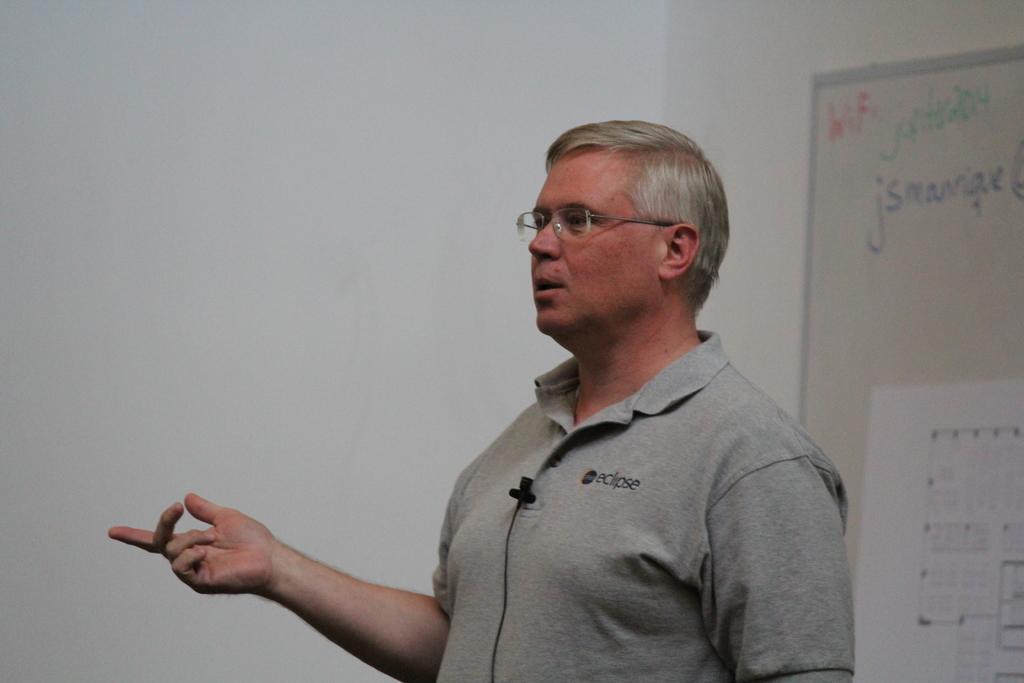Please provide a concise description of this image. A man is speaking in the microphone, he wore a t-shirt. In the right side its a board. 